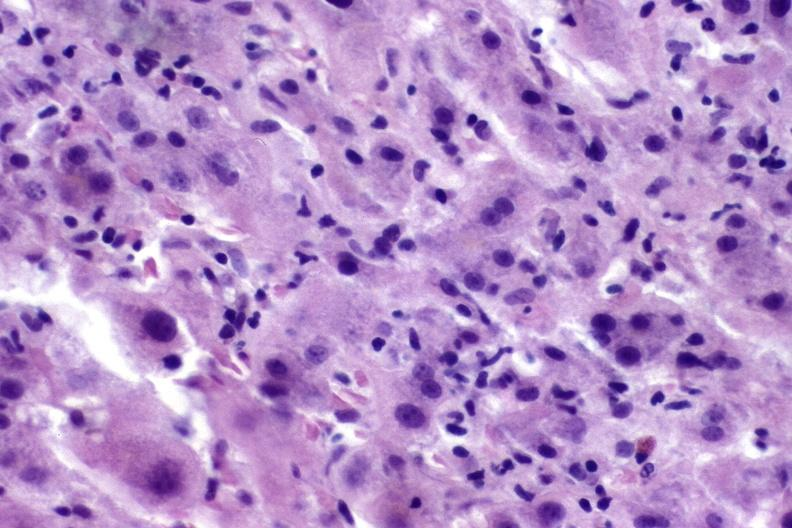what is present?
Answer the question using a single word or phrase. Hepatobiliary 